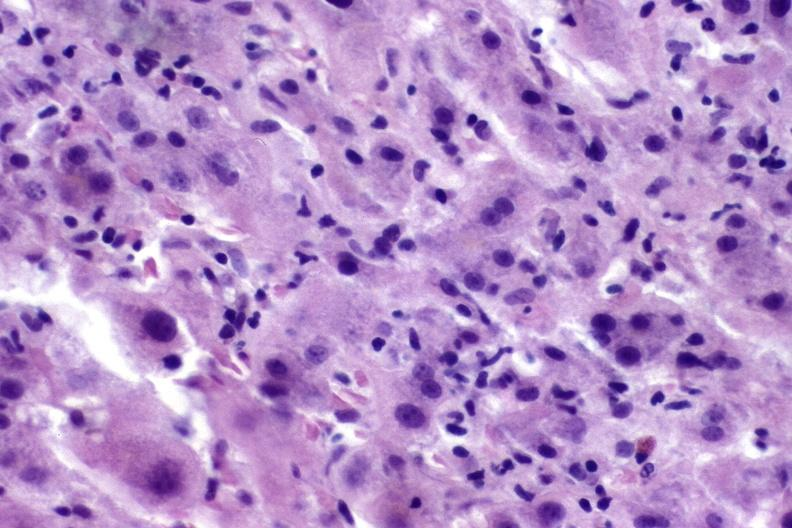what is present?
Answer the question using a single word or phrase. Hepatobiliary 